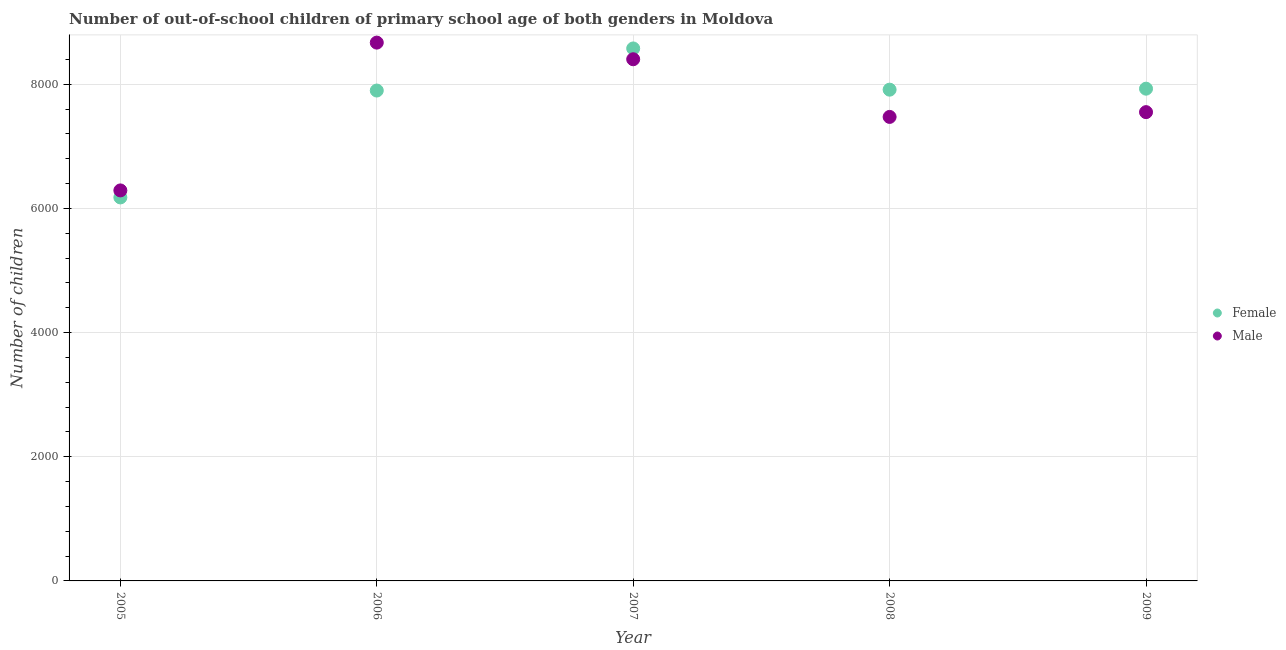What is the number of male out-of-school students in 2006?
Provide a succinct answer. 8672. Across all years, what is the maximum number of male out-of-school students?
Your response must be concise. 8672. Across all years, what is the minimum number of male out-of-school students?
Give a very brief answer. 6291. In which year was the number of female out-of-school students minimum?
Make the answer very short. 2005. What is the total number of female out-of-school students in the graph?
Ensure brevity in your answer.  3.85e+04. What is the difference between the number of male out-of-school students in 2007 and that in 2009?
Your answer should be compact. 852. What is the difference between the number of male out-of-school students in 2007 and the number of female out-of-school students in 2009?
Your response must be concise. 474. What is the average number of female out-of-school students per year?
Provide a succinct answer. 7700. In the year 2007, what is the difference between the number of female out-of-school students and number of male out-of-school students?
Ensure brevity in your answer.  174. What is the ratio of the number of male out-of-school students in 2006 to that in 2007?
Make the answer very short. 1.03. What is the difference between the highest and the second highest number of female out-of-school students?
Ensure brevity in your answer.  648. What is the difference between the highest and the lowest number of female out-of-school students?
Your answer should be compact. 2400. In how many years, is the number of male out-of-school students greater than the average number of male out-of-school students taken over all years?
Provide a succinct answer. 2. Is the sum of the number of female out-of-school students in 2005 and 2009 greater than the maximum number of male out-of-school students across all years?
Offer a very short reply. Yes. Is the number of female out-of-school students strictly greater than the number of male out-of-school students over the years?
Keep it short and to the point. No. How many dotlines are there?
Your answer should be very brief. 2. How many years are there in the graph?
Make the answer very short. 5. What is the difference between two consecutive major ticks on the Y-axis?
Provide a succinct answer. 2000. Are the values on the major ticks of Y-axis written in scientific E-notation?
Offer a very short reply. No. Does the graph contain any zero values?
Keep it short and to the point. No. Does the graph contain grids?
Provide a succinct answer. Yes. What is the title of the graph?
Provide a succinct answer. Number of out-of-school children of primary school age of both genders in Moldova. What is the label or title of the X-axis?
Give a very brief answer. Year. What is the label or title of the Y-axis?
Offer a terse response. Number of children. What is the Number of children of Female in 2005?
Your answer should be compact. 6178. What is the Number of children in Male in 2005?
Provide a succinct answer. 6291. What is the Number of children in Female in 2006?
Give a very brief answer. 7900. What is the Number of children of Male in 2006?
Make the answer very short. 8672. What is the Number of children in Female in 2007?
Keep it short and to the point. 8578. What is the Number of children of Male in 2007?
Your answer should be very brief. 8404. What is the Number of children of Female in 2008?
Keep it short and to the point. 7914. What is the Number of children of Male in 2008?
Your answer should be very brief. 7475. What is the Number of children of Female in 2009?
Your answer should be compact. 7930. What is the Number of children in Male in 2009?
Your answer should be compact. 7552. Across all years, what is the maximum Number of children in Female?
Give a very brief answer. 8578. Across all years, what is the maximum Number of children in Male?
Provide a short and direct response. 8672. Across all years, what is the minimum Number of children of Female?
Provide a short and direct response. 6178. Across all years, what is the minimum Number of children in Male?
Ensure brevity in your answer.  6291. What is the total Number of children of Female in the graph?
Your answer should be very brief. 3.85e+04. What is the total Number of children of Male in the graph?
Offer a very short reply. 3.84e+04. What is the difference between the Number of children of Female in 2005 and that in 2006?
Provide a short and direct response. -1722. What is the difference between the Number of children of Male in 2005 and that in 2006?
Provide a short and direct response. -2381. What is the difference between the Number of children in Female in 2005 and that in 2007?
Give a very brief answer. -2400. What is the difference between the Number of children of Male in 2005 and that in 2007?
Offer a very short reply. -2113. What is the difference between the Number of children of Female in 2005 and that in 2008?
Your answer should be very brief. -1736. What is the difference between the Number of children in Male in 2005 and that in 2008?
Offer a very short reply. -1184. What is the difference between the Number of children of Female in 2005 and that in 2009?
Make the answer very short. -1752. What is the difference between the Number of children of Male in 2005 and that in 2009?
Ensure brevity in your answer.  -1261. What is the difference between the Number of children in Female in 2006 and that in 2007?
Provide a succinct answer. -678. What is the difference between the Number of children in Male in 2006 and that in 2007?
Provide a succinct answer. 268. What is the difference between the Number of children of Female in 2006 and that in 2008?
Make the answer very short. -14. What is the difference between the Number of children in Male in 2006 and that in 2008?
Your response must be concise. 1197. What is the difference between the Number of children of Female in 2006 and that in 2009?
Your answer should be very brief. -30. What is the difference between the Number of children in Male in 2006 and that in 2009?
Offer a terse response. 1120. What is the difference between the Number of children of Female in 2007 and that in 2008?
Give a very brief answer. 664. What is the difference between the Number of children in Male in 2007 and that in 2008?
Your answer should be very brief. 929. What is the difference between the Number of children of Female in 2007 and that in 2009?
Your answer should be very brief. 648. What is the difference between the Number of children in Male in 2007 and that in 2009?
Your answer should be very brief. 852. What is the difference between the Number of children in Female in 2008 and that in 2009?
Make the answer very short. -16. What is the difference between the Number of children of Male in 2008 and that in 2009?
Ensure brevity in your answer.  -77. What is the difference between the Number of children of Female in 2005 and the Number of children of Male in 2006?
Your answer should be compact. -2494. What is the difference between the Number of children of Female in 2005 and the Number of children of Male in 2007?
Provide a short and direct response. -2226. What is the difference between the Number of children of Female in 2005 and the Number of children of Male in 2008?
Ensure brevity in your answer.  -1297. What is the difference between the Number of children in Female in 2005 and the Number of children in Male in 2009?
Your answer should be compact. -1374. What is the difference between the Number of children of Female in 2006 and the Number of children of Male in 2007?
Give a very brief answer. -504. What is the difference between the Number of children of Female in 2006 and the Number of children of Male in 2008?
Your response must be concise. 425. What is the difference between the Number of children in Female in 2006 and the Number of children in Male in 2009?
Your answer should be compact. 348. What is the difference between the Number of children of Female in 2007 and the Number of children of Male in 2008?
Offer a terse response. 1103. What is the difference between the Number of children in Female in 2007 and the Number of children in Male in 2009?
Offer a very short reply. 1026. What is the difference between the Number of children of Female in 2008 and the Number of children of Male in 2009?
Offer a very short reply. 362. What is the average Number of children of Female per year?
Offer a very short reply. 7700. What is the average Number of children of Male per year?
Offer a very short reply. 7678.8. In the year 2005, what is the difference between the Number of children of Female and Number of children of Male?
Offer a very short reply. -113. In the year 2006, what is the difference between the Number of children in Female and Number of children in Male?
Ensure brevity in your answer.  -772. In the year 2007, what is the difference between the Number of children of Female and Number of children of Male?
Keep it short and to the point. 174. In the year 2008, what is the difference between the Number of children in Female and Number of children in Male?
Offer a terse response. 439. In the year 2009, what is the difference between the Number of children in Female and Number of children in Male?
Provide a short and direct response. 378. What is the ratio of the Number of children in Female in 2005 to that in 2006?
Give a very brief answer. 0.78. What is the ratio of the Number of children in Male in 2005 to that in 2006?
Your answer should be compact. 0.73. What is the ratio of the Number of children of Female in 2005 to that in 2007?
Provide a short and direct response. 0.72. What is the ratio of the Number of children in Male in 2005 to that in 2007?
Provide a succinct answer. 0.75. What is the ratio of the Number of children of Female in 2005 to that in 2008?
Provide a succinct answer. 0.78. What is the ratio of the Number of children of Male in 2005 to that in 2008?
Your response must be concise. 0.84. What is the ratio of the Number of children of Female in 2005 to that in 2009?
Your answer should be very brief. 0.78. What is the ratio of the Number of children in Male in 2005 to that in 2009?
Ensure brevity in your answer.  0.83. What is the ratio of the Number of children of Female in 2006 to that in 2007?
Your answer should be very brief. 0.92. What is the ratio of the Number of children of Male in 2006 to that in 2007?
Keep it short and to the point. 1.03. What is the ratio of the Number of children of Female in 2006 to that in 2008?
Offer a very short reply. 1. What is the ratio of the Number of children in Male in 2006 to that in 2008?
Offer a terse response. 1.16. What is the ratio of the Number of children of Female in 2006 to that in 2009?
Offer a terse response. 1. What is the ratio of the Number of children in Male in 2006 to that in 2009?
Your response must be concise. 1.15. What is the ratio of the Number of children in Female in 2007 to that in 2008?
Your response must be concise. 1.08. What is the ratio of the Number of children in Male in 2007 to that in 2008?
Ensure brevity in your answer.  1.12. What is the ratio of the Number of children in Female in 2007 to that in 2009?
Ensure brevity in your answer.  1.08. What is the ratio of the Number of children in Male in 2007 to that in 2009?
Offer a terse response. 1.11. What is the ratio of the Number of children in Female in 2008 to that in 2009?
Provide a succinct answer. 1. What is the ratio of the Number of children of Male in 2008 to that in 2009?
Your answer should be very brief. 0.99. What is the difference between the highest and the second highest Number of children in Female?
Your answer should be compact. 648. What is the difference between the highest and the second highest Number of children of Male?
Your response must be concise. 268. What is the difference between the highest and the lowest Number of children of Female?
Keep it short and to the point. 2400. What is the difference between the highest and the lowest Number of children in Male?
Offer a very short reply. 2381. 